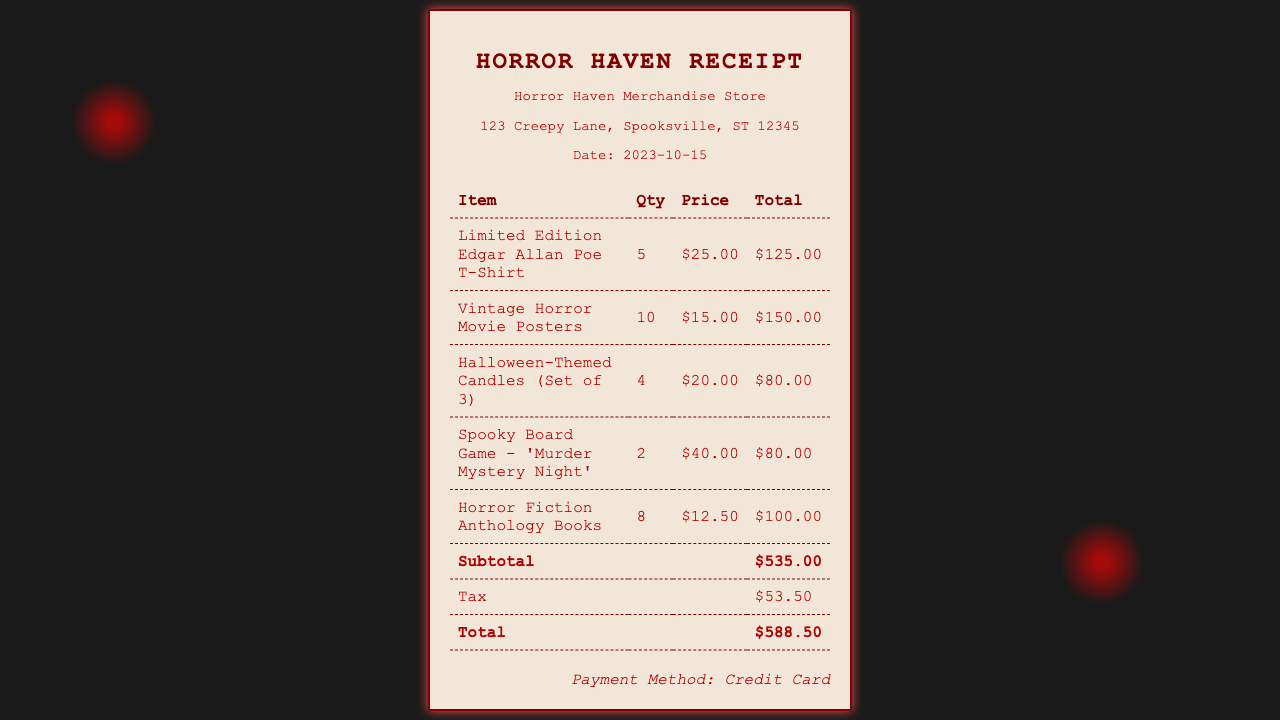What is the total cost of the items purchased? The total cost is indicated at the bottom of the receipt, which includes the subtotal and tax.
Answer: $588.50 How many Halloween-themed candles were purchased? The quantity of Halloween-themed candles is listed in the receipt under the corresponding item.
Answer: 4 What is the date on the receipt? The date is provided in the vendor info section of the receipt.
Answer: 2023-10-15 Which payment method was used for this purchase? The payment method is specified at the bottom of the receipt.
Answer: Credit Card What was the subtotal before tax? The subtotal is shown in the receipt as the sum of all item totals before tax.
Answer: $535.00 How many Vintage Horror Movie Posters were bought? The quantity for Vintage Horror Movie Posters is listed in the receipt.
Answer: 10 What is the price of one Limited Edition Edgar Allan Poe T-Shirt? The unit price of the item is displayed in the receipt.
Answer: $25.00 How many Horror Fiction Anthology Books were purchased? The quantity for Horror Fiction Anthology Books is stated in the receipt.
Answer: 8 What is the tax amount charged? The tax amount is explicitly mentioned in the receipt.
Answer: $53.50 